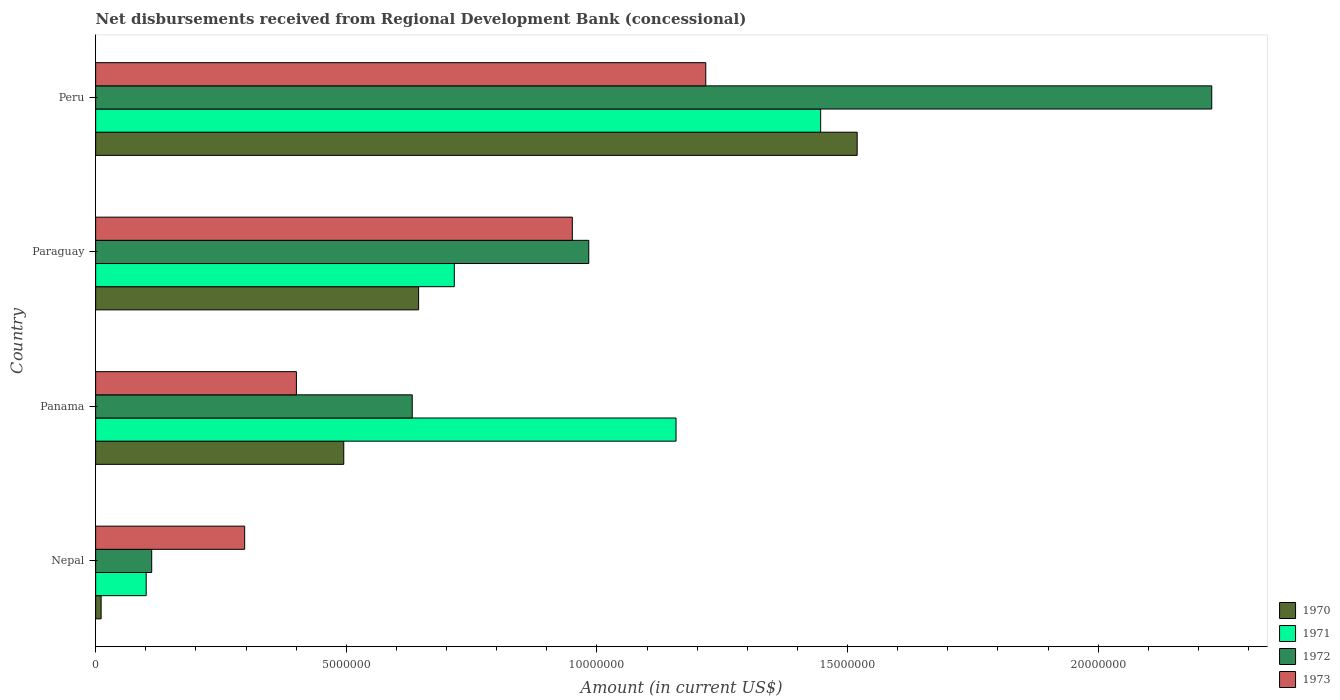How many groups of bars are there?
Ensure brevity in your answer.  4. Are the number of bars per tick equal to the number of legend labels?
Your response must be concise. Yes. How many bars are there on the 1st tick from the top?
Offer a very short reply. 4. How many bars are there on the 4th tick from the bottom?
Offer a very short reply. 4. What is the amount of disbursements received from Regional Development Bank in 1973 in Peru?
Keep it short and to the point. 1.22e+07. Across all countries, what is the maximum amount of disbursements received from Regional Development Bank in 1970?
Provide a short and direct response. 1.52e+07. Across all countries, what is the minimum amount of disbursements received from Regional Development Bank in 1970?
Keep it short and to the point. 1.09e+05. In which country was the amount of disbursements received from Regional Development Bank in 1972 maximum?
Give a very brief answer. Peru. In which country was the amount of disbursements received from Regional Development Bank in 1970 minimum?
Ensure brevity in your answer.  Nepal. What is the total amount of disbursements received from Regional Development Bank in 1970 in the graph?
Keep it short and to the point. 2.67e+07. What is the difference between the amount of disbursements received from Regional Development Bank in 1971 in Paraguay and that in Peru?
Ensure brevity in your answer.  -7.31e+06. What is the difference between the amount of disbursements received from Regional Development Bank in 1971 in Panama and the amount of disbursements received from Regional Development Bank in 1970 in Nepal?
Keep it short and to the point. 1.15e+07. What is the average amount of disbursements received from Regional Development Bank in 1970 per country?
Ensure brevity in your answer.  6.67e+06. What is the difference between the amount of disbursements received from Regional Development Bank in 1970 and amount of disbursements received from Regional Development Bank in 1973 in Nepal?
Your response must be concise. -2.86e+06. In how many countries, is the amount of disbursements received from Regional Development Bank in 1973 greater than 13000000 US$?
Offer a terse response. 0. What is the ratio of the amount of disbursements received from Regional Development Bank in 1970 in Panama to that in Peru?
Keep it short and to the point. 0.33. What is the difference between the highest and the second highest amount of disbursements received from Regional Development Bank in 1972?
Give a very brief answer. 1.24e+07. What is the difference between the highest and the lowest amount of disbursements received from Regional Development Bank in 1973?
Your response must be concise. 9.20e+06. What does the 4th bar from the top in Peru represents?
Keep it short and to the point. 1970. Is it the case that in every country, the sum of the amount of disbursements received from Regional Development Bank in 1971 and amount of disbursements received from Regional Development Bank in 1972 is greater than the amount of disbursements received from Regional Development Bank in 1973?
Offer a terse response. No. How many bars are there?
Offer a very short reply. 16. Does the graph contain any zero values?
Your answer should be compact. No. Where does the legend appear in the graph?
Offer a terse response. Bottom right. How are the legend labels stacked?
Your answer should be compact. Vertical. What is the title of the graph?
Make the answer very short. Net disbursements received from Regional Development Bank (concessional). Does "1998" appear as one of the legend labels in the graph?
Give a very brief answer. No. What is the label or title of the Y-axis?
Offer a terse response. Country. What is the Amount (in current US$) of 1970 in Nepal?
Keep it short and to the point. 1.09e+05. What is the Amount (in current US$) in 1971 in Nepal?
Offer a very short reply. 1.01e+06. What is the Amount (in current US$) of 1972 in Nepal?
Offer a terse response. 1.12e+06. What is the Amount (in current US$) of 1973 in Nepal?
Provide a succinct answer. 2.97e+06. What is the Amount (in current US$) of 1970 in Panama?
Your answer should be compact. 4.95e+06. What is the Amount (in current US$) of 1971 in Panama?
Make the answer very short. 1.16e+07. What is the Amount (in current US$) in 1972 in Panama?
Your answer should be very brief. 6.32e+06. What is the Amount (in current US$) in 1973 in Panama?
Provide a short and direct response. 4.00e+06. What is the Amount (in current US$) in 1970 in Paraguay?
Provide a short and direct response. 6.44e+06. What is the Amount (in current US$) in 1971 in Paraguay?
Provide a short and direct response. 7.16e+06. What is the Amount (in current US$) in 1972 in Paraguay?
Offer a very short reply. 9.84e+06. What is the Amount (in current US$) in 1973 in Paraguay?
Keep it short and to the point. 9.51e+06. What is the Amount (in current US$) of 1970 in Peru?
Offer a very short reply. 1.52e+07. What is the Amount (in current US$) in 1971 in Peru?
Offer a terse response. 1.45e+07. What is the Amount (in current US$) in 1972 in Peru?
Your answer should be very brief. 2.23e+07. What is the Amount (in current US$) in 1973 in Peru?
Provide a succinct answer. 1.22e+07. Across all countries, what is the maximum Amount (in current US$) in 1970?
Give a very brief answer. 1.52e+07. Across all countries, what is the maximum Amount (in current US$) of 1971?
Your response must be concise. 1.45e+07. Across all countries, what is the maximum Amount (in current US$) in 1972?
Offer a terse response. 2.23e+07. Across all countries, what is the maximum Amount (in current US$) in 1973?
Ensure brevity in your answer.  1.22e+07. Across all countries, what is the minimum Amount (in current US$) of 1970?
Offer a terse response. 1.09e+05. Across all countries, what is the minimum Amount (in current US$) of 1971?
Ensure brevity in your answer.  1.01e+06. Across all countries, what is the minimum Amount (in current US$) in 1972?
Give a very brief answer. 1.12e+06. Across all countries, what is the minimum Amount (in current US$) in 1973?
Your answer should be compact. 2.97e+06. What is the total Amount (in current US$) of 1970 in the graph?
Provide a succinct answer. 2.67e+07. What is the total Amount (in current US$) in 1971 in the graph?
Make the answer very short. 3.42e+07. What is the total Amount (in current US$) in 1972 in the graph?
Your answer should be compact. 3.95e+07. What is the total Amount (in current US$) of 1973 in the graph?
Provide a short and direct response. 2.87e+07. What is the difference between the Amount (in current US$) in 1970 in Nepal and that in Panama?
Offer a very short reply. -4.84e+06. What is the difference between the Amount (in current US$) in 1971 in Nepal and that in Panama?
Keep it short and to the point. -1.06e+07. What is the difference between the Amount (in current US$) in 1972 in Nepal and that in Panama?
Offer a terse response. -5.20e+06. What is the difference between the Amount (in current US$) in 1973 in Nepal and that in Panama?
Offer a terse response. -1.03e+06. What is the difference between the Amount (in current US$) of 1970 in Nepal and that in Paraguay?
Ensure brevity in your answer.  -6.33e+06. What is the difference between the Amount (in current US$) of 1971 in Nepal and that in Paraguay?
Offer a terse response. -6.15e+06. What is the difference between the Amount (in current US$) in 1972 in Nepal and that in Paraguay?
Provide a short and direct response. -8.72e+06. What is the difference between the Amount (in current US$) in 1973 in Nepal and that in Paraguay?
Your answer should be very brief. -6.54e+06. What is the difference between the Amount (in current US$) in 1970 in Nepal and that in Peru?
Your response must be concise. -1.51e+07. What is the difference between the Amount (in current US$) in 1971 in Nepal and that in Peru?
Keep it short and to the point. -1.35e+07. What is the difference between the Amount (in current US$) of 1972 in Nepal and that in Peru?
Ensure brevity in your answer.  -2.11e+07. What is the difference between the Amount (in current US$) of 1973 in Nepal and that in Peru?
Your response must be concise. -9.20e+06. What is the difference between the Amount (in current US$) of 1970 in Panama and that in Paraguay?
Your answer should be compact. -1.49e+06. What is the difference between the Amount (in current US$) in 1971 in Panama and that in Paraguay?
Provide a succinct answer. 4.42e+06. What is the difference between the Amount (in current US$) in 1972 in Panama and that in Paraguay?
Ensure brevity in your answer.  -3.52e+06. What is the difference between the Amount (in current US$) in 1973 in Panama and that in Paraguay?
Ensure brevity in your answer.  -5.50e+06. What is the difference between the Amount (in current US$) in 1970 in Panama and that in Peru?
Make the answer very short. -1.02e+07. What is the difference between the Amount (in current US$) in 1971 in Panama and that in Peru?
Provide a succinct answer. -2.88e+06. What is the difference between the Amount (in current US$) of 1972 in Panama and that in Peru?
Ensure brevity in your answer.  -1.60e+07. What is the difference between the Amount (in current US$) in 1973 in Panama and that in Peru?
Provide a succinct answer. -8.17e+06. What is the difference between the Amount (in current US$) of 1970 in Paraguay and that in Peru?
Your answer should be very brief. -8.75e+06. What is the difference between the Amount (in current US$) in 1971 in Paraguay and that in Peru?
Your answer should be compact. -7.31e+06. What is the difference between the Amount (in current US$) in 1972 in Paraguay and that in Peru?
Your response must be concise. -1.24e+07. What is the difference between the Amount (in current US$) of 1973 in Paraguay and that in Peru?
Offer a terse response. -2.66e+06. What is the difference between the Amount (in current US$) of 1970 in Nepal and the Amount (in current US$) of 1971 in Panama?
Offer a terse response. -1.15e+07. What is the difference between the Amount (in current US$) in 1970 in Nepal and the Amount (in current US$) in 1972 in Panama?
Offer a very short reply. -6.21e+06. What is the difference between the Amount (in current US$) in 1970 in Nepal and the Amount (in current US$) in 1973 in Panama?
Give a very brief answer. -3.90e+06. What is the difference between the Amount (in current US$) of 1971 in Nepal and the Amount (in current US$) of 1972 in Panama?
Keep it short and to the point. -5.31e+06. What is the difference between the Amount (in current US$) of 1971 in Nepal and the Amount (in current US$) of 1973 in Panama?
Provide a succinct answer. -3.00e+06. What is the difference between the Amount (in current US$) in 1972 in Nepal and the Amount (in current US$) in 1973 in Panama?
Make the answer very short. -2.89e+06. What is the difference between the Amount (in current US$) of 1970 in Nepal and the Amount (in current US$) of 1971 in Paraguay?
Provide a succinct answer. -7.05e+06. What is the difference between the Amount (in current US$) of 1970 in Nepal and the Amount (in current US$) of 1972 in Paraguay?
Make the answer very short. -9.73e+06. What is the difference between the Amount (in current US$) of 1970 in Nepal and the Amount (in current US$) of 1973 in Paraguay?
Give a very brief answer. -9.40e+06. What is the difference between the Amount (in current US$) of 1971 in Nepal and the Amount (in current US$) of 1972 in Paraguay?
Make the answer very short. -8.83e+06. What is the difference between the Amount (in current US$) in 1971 in Nepal and the Amount (in current US$) in 1973 in Paraguay?
Provide a short and direct response. -8.50e+06. What is the difference between the Amount (in current US$) of 1972 in Nepal and the Amount (in current US$) of 1973 in Paraguay?
Provide a short and direct response. -8.39e+06. What is the difference between the Amount (in current US$) in 1970 in Nepal and the Amount (in current US$) in 1971 in Peru?
Keep it short and to the point. -1.44e+07. What is the difference between the Amount (in current US$) of 1970 in Nepal and the Amount (in current US$) of 1972 in Peru?
Ensure brevity in your answer.  -2.22e+07. What is the difference between the Amount (in current US$) in 1970 in Nepal and the Amount (in current US$) in 1973 in Peru?
Your answer should be compact. -1.21e+07. What is the difference between the Amount (in current US$) in 1971 in Nepal and the Amount (in current US$) in 1972 in Peru?
Make the answer very short. -2.13e+07. What is the difference between the Amount (in current US$) of 1971 in Nepal and the Amount (in current US$) of 1973 in Peru?
Give a very brief answer. -1.12e+07. What is the difference between the Amount (in current US$) of 1972 in Nepal and the Amount (in current US$) of 1973 in Peru?
Provide a short and direct response. -1.11e+07. What is the difference between the Amount (in current US$) of 1970 in Panama and the Amount (in current US$) of 1971 in Paraguay?
Provide a short and direct response. -2.20e+06. What is the difference between the Amount (in current US$) in 1970 in Panama and the Amount (in current US$) in 1972 in Paraguay?
Your answer should be very brief. -4.89e+06. What is the difference between the Amount (in current US$) of 1970 in Panama and the Amount (in current US$) of 1973 in Paraguay?
Make the answer very short. -4.56e+06. What is the difference between the Amount (in current US$) of 1971 in Panama and the Amount (in current US$) of 1972 in Paraguay?
Ensure brevity in your answer.  1.74e+06. What is the difference between the Amount (in current US$) in 1971 in Panama and the Amount (in current US$) in 1973 in Paraguay?
Your answer should be very brief. 2.07e+06. What is the difference between the Amount (in current US$) in 1972 in Panama and the Amount (in current US$) in 1973 in Paraguay?
Provide a succinct answer. -3.19e+06. What is the difference between the Amount (in current US$) of 1970 in Panama and the Amount (in current US$) of 1971 in Peru?
Your answer should be compact. -9.51e+06. What is the difference between the Amount (in current US$) in 1970 in Panama and the Amount (in current US$) in 1972 in Peru?
Offer a terse response. -1.73e+07. What is the difference between the Amount (in current US$) in 1970 in Panama and the Amount (in current US$) in 1973 in Peru?
Provide a short and direct response. -7.22e+06. What is the difference between the Amount (in current US$) in 1971 in Panama and the Amount (in current US$) in 1972 in Peru?
Provide a short and direct response. -1.07e+07. What is the difference between the Amount (in current US$) in 1971 in Panama and the Amount (in current US$) in 1973 in Peru?
Your answer should be very brief. -5.93e+05. What is the difference between the Amount (in current US$) of 1972 in Panama and the Amount (in current US$) of 1973 in Peru?
Provide a short and direct response. -5.86e+06. What is the difference between the Amount (in current US$) of 1970 in Paraguay and the Amount (in current US$) of 1971 in Peru?
Offer a very short reply. -8.02e+06. What is the difference between the Amount (in current US$) in 1970 in Paraguay and the Amount (in current US$) in 1972 in Peru?
Provide a succinct answer. -1.58e+07. What is the difference between the Amount (in current US$) of 1970 in Paraguay and the Amount (in current US$) of 1973 in Peru?
Make the answer very short. -5.73e+06. What is the difference between the Amount (in current US$) in 1971 in Paraguay and the Amount (in current US$) in 1972 in Peru?
Your response must be concise. -1.51e+07. What is the difference between the Amount (in current US$) in 1971 in Paraguay and the Amount (in current US$) in 1973 in Peru?
Give a very brief answer. -5.02e+06. What is the difference between the Amount (in current US$) of 1972 in Paraguay and the Amount (in current US$) of 1973 in Peru?
Your answer should be compact. -2.33e+06. What is the average Amount (in current US$) of 1970 per country?
Your response must be concise. 6.67e+06. What is the average Amount (in current US$) in 1971 per country?
Keep it short and to the point. 8.55e+06. What is the average Amount (in current US$) in 1972 per country?
Your answer should be very brief. 9.88e+06. What is the average Amount (in current US$) in 1973 per country?
Keep it short and to the point. 7.16e+06. What is the difference between the Amount (in current US$) of 1970 and Amount (in current US$) of 1971 in Nepal?
Provide a succinct answer. -8.99e+05. What is the difference between the Amount (in current US$) in 1970 and Amount (in current US$) in 1972 in Nepal?
Your answer should be compact. -1.01e+06. What is the difference between the Amount (in current US$) in 1970 and Amount (in current US$) in 1973 in Nepal?
Keep it short and to the point. -2.86e+06. What is the difference between the Amount (in current US$) of 1971 and Amount (in current US$) of 1973 in Nepal?
Your answer should be very brief. -1.96e+06. What is the difference between the Amount (in current US$) in 1972 and Amount (in current US$) in 1973 in Nepal?
Your response must be concise. -1.86e+06. What is the difference between the Amount (in current US$) in 1970 and Amount (in current US$) in 1971 in Panama?
Offer a very short reply. -6.63e+06. What is the difference between the Amount (in current US$) in 1970 and Amount (in current US$) in 1972 in Panama?
Keep it short and to the point. -1.37e+06. What is the difference between the Amount (in current US$) in 1970 and Amount (in current US$) in 1973 in Panama?
Offer a very short reply. 9.45e+05. What is the difference between the Amount (in current US$) in 1971 and Amount (in current US$) in 1972 in Panama?
Keep it short and to the point. 5.26e+06. What is the difference between the Amount (in current US$) in 1971 and Amount (in current US$) in 1973 in Panama?
Provide a short and direct response. 7.57e+06. What is the difference between the Amount (in current US$) in 1972 and Amount (in current US$) in 1973 in Panama?
Keep it short and to the point. 2.31e+06. What is the difference between the Amount (in current US$) of 1970 and Amount (in current US$) of 1971 in Paraguay?
Offer a terse response. -7.12e+05. What is the difference between the Amount (in current US$) in 1970 and Amount (in current US$) in 1972 in Paraguay?
Offer a very short reply. -3.40e+06. What is the difference between the Amount (in current US$) of 1970 and Amount (in current US$) of 1973 in Paraguay?
Provide a short and direct response. -3.07e+06. What is the difference between the Amount (in current US$) of 1971 and Amount (in current US$) of 1972 in Paraguay?
Ensure brevity in your answer.  -2.68e+06. What is the difference between the Amount (in current US$) in 1971 and Amount (in current US$) in 1973 in Paraguay?
Ensure brevity in your answer.  -2.36e+06. What is the difference between the Amount (in current US$) in 1972 and Amount (in current US$) in 1973 in Paraguay?
Provide a succinct answer. 3.28e+05. What is the difference between the Amount (in current US$) of 1970 and Amount (in current US$) of 1971 in Peru?
Your answer should be compact. 7.29e+05. What is the difference between the Amount (in current US$) in 1970 and Amount (in current US$) in 1972 in Peru?
Your answer should be compact. -7.07e+06. What is the difference between the Amount (in current US$) in 1970 and Amount (in current US$) in 1973 in Peru?
Provide a short and direct response. 3.02e+06. What is the difference between the Amount (in current US$) of 1971 and Amount (in current US$) of 1972 in Peru?
Your answer should be compact. -7.80e+06. What is the difference between the Amount (in current US$) of 1971 and Amount (in current US$) of 1973 in Peru?
Offer a very short reply. 2.29e+06. What is the difference between the Amount (in current US$) of 1972 and Amount (in current US$) of 1973 in Peru?
Keep it short and to the point. 1.01e+07. What is the ratio of the Amount (in current US$) in 1970 in Nepal to that in Panama?
Ensure brevity in your answer.  0.02. What is the ratio of the Amount (in current US$) of 1971 in Nepal to that in Panama?
Give a very brief answer. 0.09. What is the ratio of the Amount (in current US$) in 1972 in Nepal to that in Panama?
Your answer should be very brief. 0.18. What is the ratio of the Amount (in current US$) of 1973 in Nepal to that in Panama?
Make the answer very short. 0.74. What is the ratio of the Amount (in current US$) in 1970 in Nepal to that in Paraguay?
Your answer should be compact. 0.02. What is the ratio of the Amount (in current US$) in 1971 in Nepal to that in Paraguay?
Ensure brevity in your answer.  0.14. What is the ratio of the Amount (in current US$) in 1972 in Nepal to that in Paraguay?
Your answer should be compact. 0.11. What is the ratio of the Amount (in current US$) of 1973 in Nepal to that in Paraguay?
Provide a short and direct response. 0.31. What is the ratio of the Amount (in current US$) in 1970 in Nepal to that in Peru?
Keep it short and to the point. 0.01. What is the ratio of the Amount (in current US$) in 1971 in Nepal to that in Peru?
Offer a terse response. 0.07. What is the ratio of the Amount (in current US$) in 1972 in Nepal to that in Peru?
Make the answer very short. 0.05. What is the ratio of the Amount (in current US$) in 1973 in Nepal to that in Peru?
Offer a terse response. 0.24. What is the ratio of the Amount (in current US$) in 1970 in Panama to that in Paraguay?
Give a very brief answer. 0.77. What is the ratio of the Amount (in current US$) of 1971 in Panama to that in Paraguay?
Provide a succinct answer. 1.62. What is the ratio of the Amount (in current US$) of 1972 in Panama to that in Paraguay?
Offer a very short reply. 0.64. What is the ratio of the Amount (in current US$) of 1973 in Panama to that in Paraguay?
Your answer should be compact. 0.42. What is the ratio of the Amount (in current US$) of 1970 in Panama to that in Peru?
Offer a very short reply. 0.33. What is the ratio of the Amount (in current US$) of 1971 in Panama to that in Peru?
Make the answer very short. 0.8. What is the ratio of the Amount (in current US$) in 1972 in Panama to that in Peru?
Your answer should be very brief. 0.28. What is the ratio of the Amount (in current US$) in 1973 in Panama to that in Peru?
Make the answer very short. 0.33. What is the ratio of the Amount (in current US$) of 1970 in Paraguay to that in Peru?
Provide a succinct answer. 0.42. What is the ratio of the Amount (in current US$) in 1971 in Paraguay to that in Peru?
Your answer should be very brief. 0.49. What is the ratio of the Amount (in current US$) of 1972 in Paraguay to that in Peru?
Provide a short and direct response. 0.44. What is the ratio of the Amount (in current US$) of 1973 in Paraguay to that in Peru?
Provide a short and direct response. 0.78. What is the difference between the highest and the second highest Amount (in current US$) of 1970?
Provide a succinct answer. 8.75e+06. What is the difference between the highest and the second highest Amount (in current US$) of 1971?
Your answer should be compact. 2.88e+06. What is the difference between the highest and the second highest Amount (in current US$) of 1972?
Provide a short and direct response. 1.24e+07. What is the difference between the highest and the second highest Amount (in current US$) of 1973?
Keep it short and to the point. 2.66e+06. What is the difference between the highest and the lowest Amount (in current US$) in 1970?
Provide a succinct answer. 1.51e+07. What is the difference between the highest and the lowest Amount (in current US$) of 1971?
Provide a short and direct response. 1.35e+07. What is the difference between the highest and the lowest Amount (in current US$) of 1972?
Your answer should be compact. 2.11e+07. What is the difference between the highest and the lowest Amount (in current US$) of 1973?
Provide a succinct answer. 9.20e+06. 